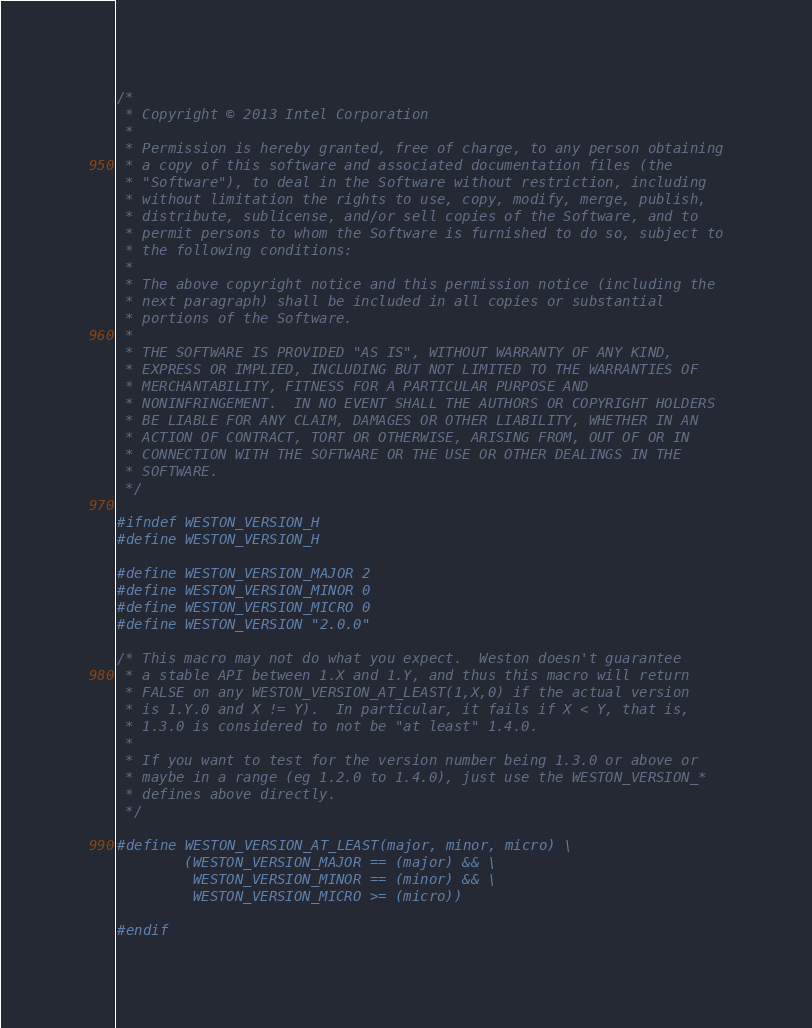Convert code to text. <code><loc_0><loc_0><loc_500><loc_500><_C_>/*
 * Copyright © 2013 Intel Corporation
 *
 * Permission is hereby granted, free of charge, to any person obtaining
 * a copy of this software and associated documentation files (the
 * "Software"), to deal in the Software without restriction, including
 * without limitation the rights to use, copy, modify, merge, publish,
 * distribute, sublicense, and/or sell copies of the Software, and to
 * permit persons to whom the Software is furnished to do so, subject to
 * the following conditions:
 *
 * The above copyright notice and this permission notice (including the
 * next paragraph) shall be included in all copies or substantial
 * portions of the Software.
 *
 * THE SOFTWARE IS PROVIDED "AS IS", WITHOUT WARRANTY OF ANY KIND,
 * EXPRESS OR IMPLIED, INCLUDING BUT NOT LIMITED TO THE WARRANTIES OF
 * MERCHANTABILITY, FITNESS FOR A PARTICULAR PURPOSE AND
 * NONINFRINGEMENT.  IN NO EVENT SHALL THE AUTHORS OR COPYRIGHT HOLDERS
 * BE LIABLE FOR ANY CLAIM, DAMAGES OR OTHER LIABILITY, WHETHER IN AN
 * ACTION OF CONTRACT, TORT OR OTHERWISE, ARISING FROM, OUT OF OR IN
 * CONNECTION WITH THE SOFTWARE OR THE USE OR OTHER DEALINGS IN THE
 * SOFTWARE.
 */

#ifndef WESTON_VERSION_H
#define WESTON_VERSION_H

#define WESTON_VERSION_MAJOR 2
#define WESTON_VERSION_MINOR 0
#define WESTON_VERSION_MICRO 0
#define WESTON_VERSION "2.0.0"

/* This macro may not do what you expect.  Weston doesn't guarantee
 * a stable API between 1.X and 1.Y, and thus this macro will return
 * FALSE on any WESTON_VERSION_AT_LEAST(1,X,0) if the actual version
 * is 1.Y.0 and X != Y).  In particular, it fails if X < Y, that is,
 * 1.3.0 is considered to not be "at least" 1.4.0.
 *
 * If you want to test for the version number being 1.3.0 or above or
 * maybe in a range (eg 1.2.0 to 1.4.0), just use the WESTON_VERSION_*
 * defines above directly.
 */

#define WESTON_VERSION_AT_LEAST(major, minor, micro) \
        (WESTON_VERSION_MAJOR == (major) && \
         WESTON_VERSION_MINOR == (minor) && \
         WESTON_VERSION_MICRO >= (micro))

#endif
</code> 